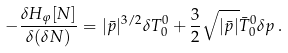<formula> <loc_0><loc_0><loc_500><loc_500>- \frac { \delta H _ { \varphi } [ N ] } { \delta ( \delta N ) } = | \bar { p } | ^ { 3 / 2 } \delta T ^ { 0 } _ { 0 } + \frac { 3 } { 2 } \sqrt { | \bar { p } | } \bar { T } ^ { 0 } _ { 0 } \delta p \, .</formula> 